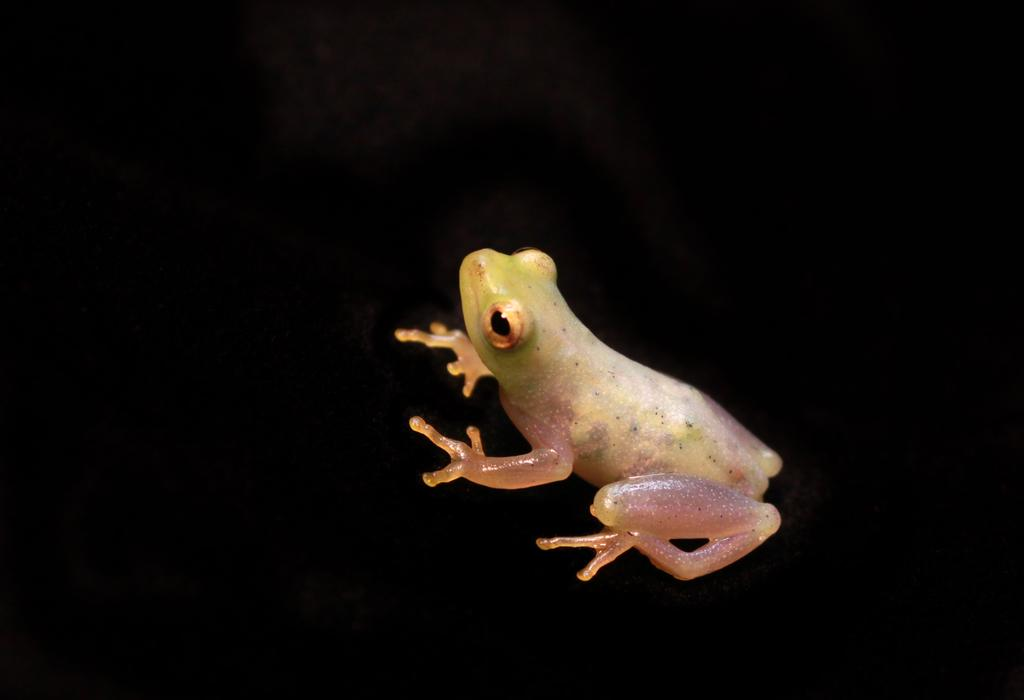What is the main subject of the image? The main subject of the image is a frog. What can be observed about the background of the image? The background of the image is dark. What type of field can be seen in the background of the image? There is no field present in the image; the background is dark. What kind of meal is being prepared in the image? There is no meal preparation visible in the image; it features a frog with a dark background. 